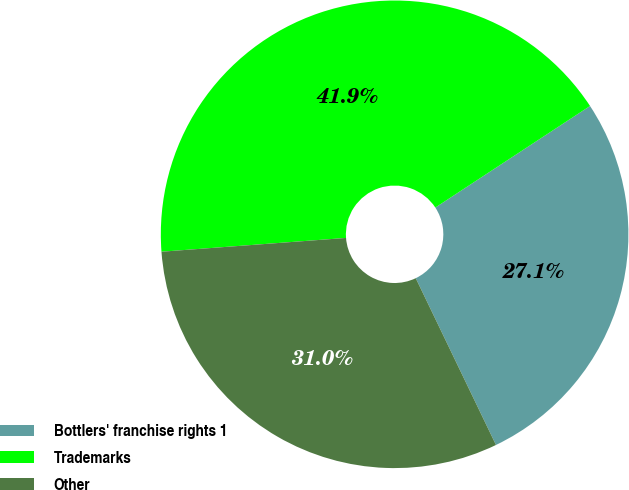Convert chart to OTSL. <chart><loc_0><loc_0><loc_500><loc_500><pie_chart><fcel>Bottlers' franchise rights 1<fcel>Trademarks<fcel>Other<nl><fcel>27.11%<fcel>41.94%<fcel>30.95%<nl></chart> 